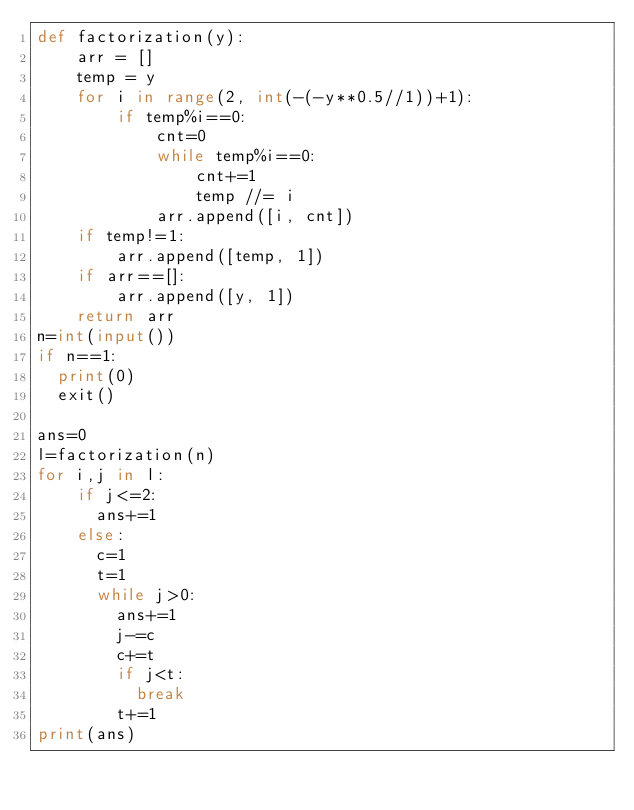<code> <loc_0><loc_0><loc_500><loc_500><_Python_>def factorization(y):
    arr = []
    temp = y
    for i in range(2, int(-(-y**0.5//1))+1):
        if temp%i==0:
            cnt=0
            while temp%i==0:
                cnt+=1
                temp //= i
            arr.append([i, cnt])
    if temp!=1:
        arr.append([temp, 1])
    if arr==[]:
        arr.append([y, 1])
    return arr
n=int(input())
if n==1:
  print(0)
  exit()

ans=0
l=factorization(n)
for i,j in l:
    if j<=2:
      ans+=1
    else:
      c=1
      t=1
      while j>0:
        ans+=1
        j-=c
        c+=t
        if j<t:
          break
        t+=1     
print(ans)</code> 